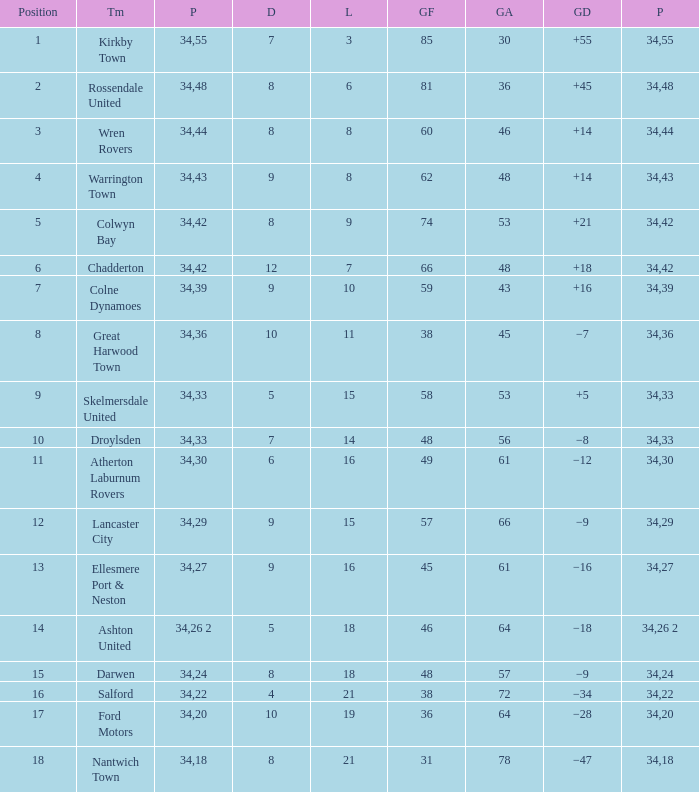What is the total number of goals for when the drawn is less than 7, less than 21 games have been lost, and there are 1 of 33 points? 1.0. Give me the full table as a dictionary. {'header': ['Position', 'Tm', 'P', 'D', 'L', 'GF', 'GA', 'GD', 'P'], 'rows': [['1', 'Kirkby Town', '34', '7', '3', '85', '30', '+55', '55'], ['2', 'Rossendale United', '34', '8', '6', '81', '36', '+45', '48'], ['3', 'Wren Rovers', '34', '8', '8', '60', '46', '+14', '44'], ['4', 'Warrington Town', '34', '9', '8', '62', '48', '+14', '43'], ['5', 'Colwyn Bay', '34', '8', '9', '74', '53', '+21', '42'], ['6', 'Chadderton', '34', '12', '7', '66', '48', '+18', '42'], ['7', 'Colne Dynamoes', '34', '9', '10', '59', '43', '+16', '39'], ['8', 'Great Harwood Town', '34', '10', '11', '38', '45', '−7', '36'], ['9', 'Skelmersdale United', '34', '5', '15', '58', '53', '+5', '33'], ['10', 'Droylsden', '34', '7', '14', '48', '56', '−8', '33'], ['11', 'Atherton Laburnum Rovers', '34', '6', '16', '49', '61', '−12', '30'], ['12', 'Lancaster City', '34', '9', '15', '57', '66', '−9', '29'], ['13', 'Ellesmere Port & Neston', '34', '9', '16', '45', '61', '−16', '27'], ['14', 'Ashton United', '34', '5', '18', '46', '64', '−18', '26 2'], ['15', 'Darwen', '34', '8', '18', '48', '57', '−9', '24'], ['16', 'Salford', '34', '4', '21', '38', '72', '−34', '22'], ['17', 'Ford Motors', '34', '10', '19', '36', '64', '−28', '20'], ['18', 'Nantwich Town', '34', '8', '21', '31', '78', '−47', '18']]} 